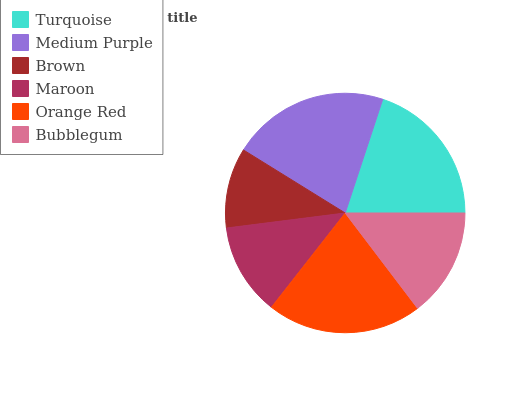Is Brown the minimum?
Answer yes or no. Yes. Is Medium Purple the maximum?
Answer yes or no. Yes. Is Medium Purple the minimum?
Answer yes or no. No. Is Brown the maximum?
Answer yes or no. No. Is Medium Purple greater than Brown?
Answer yes or no. Yes. Is Brown less than Medium Purple?
Answer yes or no. Yes. Is Brown greater than Medium Purple?
Answer yes or no. No. Is Medium Purple less than Brown?
Answer yes or no. No. Is Turquoise the high median?
Answer yes or no. Yes. Is Bubblegum the low median?
Answer yes or no. Yes. Is Maroon the high median?
Answer yes or no. No. Is Turquoise the low median?
Answer yes or no. No. 